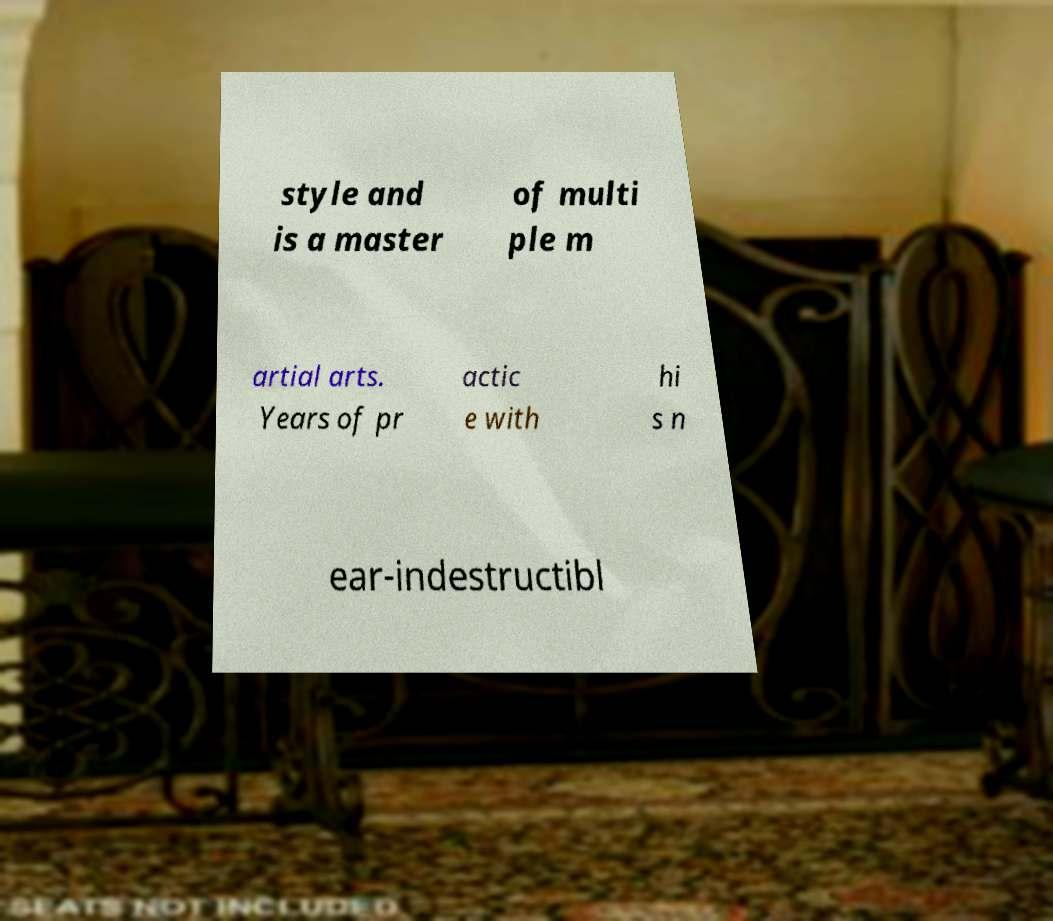Could you assist in decoding the text presented in this image and type it out clearly? style and is a master of multi ple m artial arts. Years of pr actic e with hi s n ear-indestructibl 